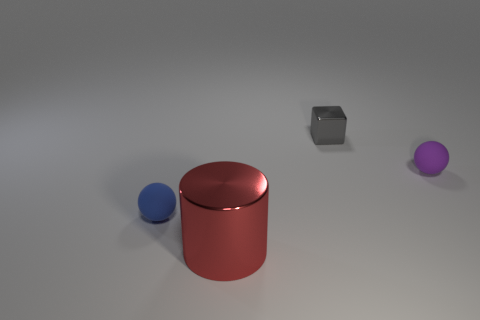Add 4 purple rubber objects. How many objects exist? 8 Subtract all cubes. How many objects are left? 3 Add 1 small purple balls. How many small purple balls are left? 2 Add 3 big brown matte cylinders. How many big brown matte cylinders exist? 3 Subtract 1 red cylinders. How many objects are left? 3 Subtract all tiny rubber things. Subtract all cylinders. How many objects are left? 1 